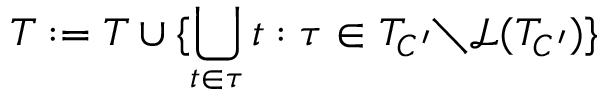Convert formula to latex. <formula><loc_0><loc_0><loc_500><loc_500>T \colon = T \cup \{ \bigcup _ { t \in \tau } t \colon \tau \in T _ { C ^ { \prime } } { \ } \mathcal { L } ( T _ { C ^ { \prime } } ) \}</formula> 